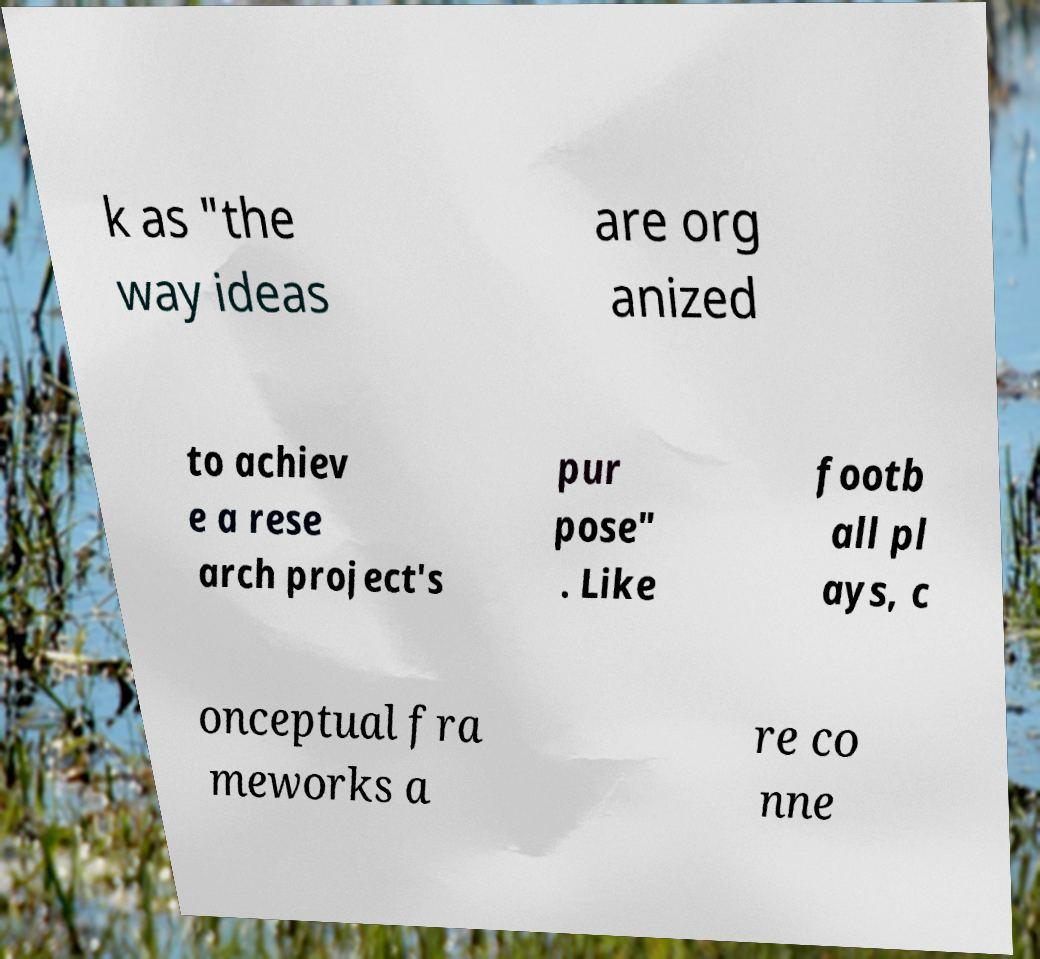What messages or text are displayed in this image? I need them in a readable, typed format. k as "the way ideas are org anized to achiev e a rese arch project's pur pose" . Like footb all pl ays, c onceptual fra meworks a re co nne 